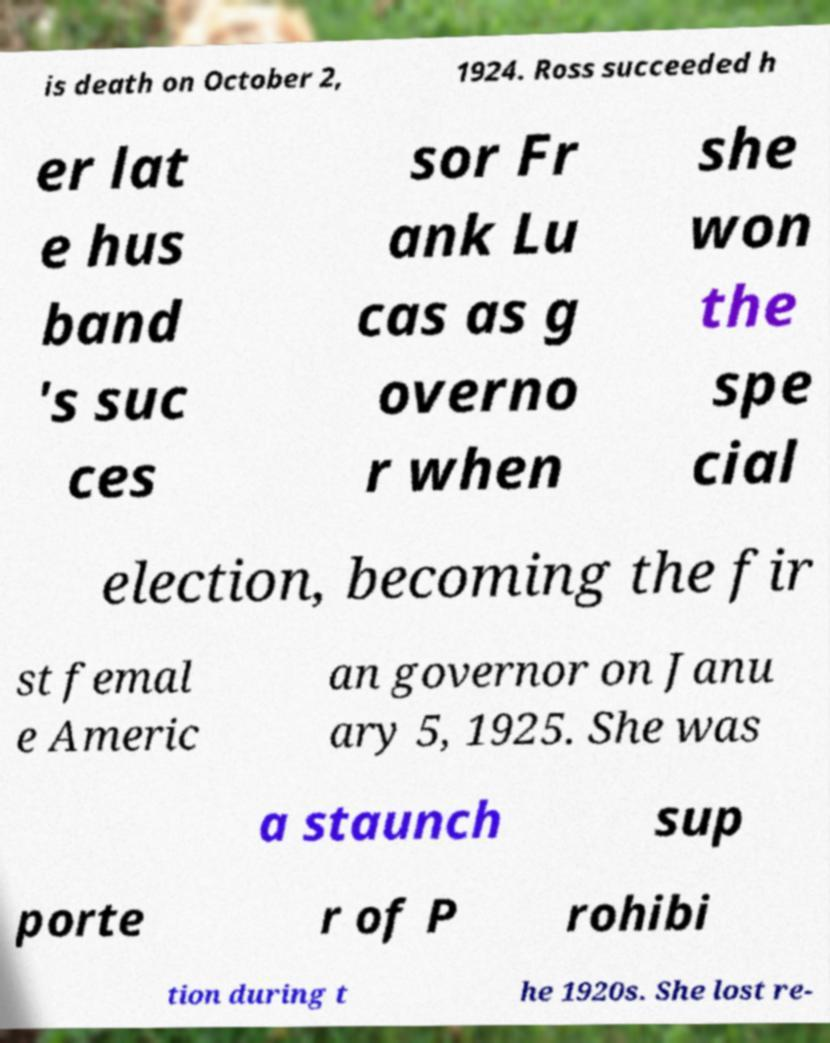Please read and relay the text visible in this image. What does it say? is death on October 2, 1924. Ross succeeded h er lat e hus band 's suc ces sor Fr ank Lu cas as g overno r when she won the spe cial election, becoming the fir st femal e Americ an governor on Janu ary 5, 1925. She was a staunch sup porte r of P rohibi tion during t he 1920s. She lost re- 